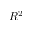<formula> <loc_0><loc_0><loc_500><loc_500>R ^ { 2 }</formula> 